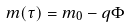Convert formula to latex. <formula><loc_0><loc_0><loc_500><loc_500>m ( \tau ) = m _ { 0 } - q \Phi</formula> 